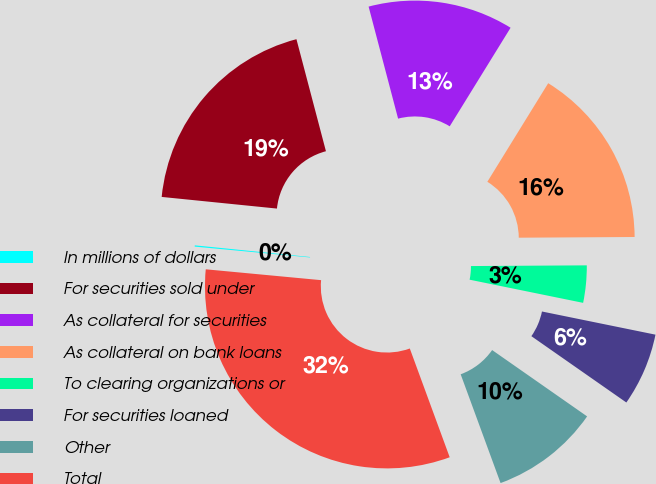<chart> <loc_0><loc_0><loc_500><loc_500><pie_chart><fcel>In millions of dollars<fcel>For securities sold under<fcel>As collateral for securities<fcel>As collateral on bank loans<fcel>To clearing organizations or<fcel>For securities loaned<fcel>Other<fcel>Total<nl><fcel>0.11%<fcel>19.3%<fcel>12.9%<fcel>16.1%<fcel>3.3%<fcel>6.5%<fcel>9.7%<fcel>32.09%<nl></chart> 